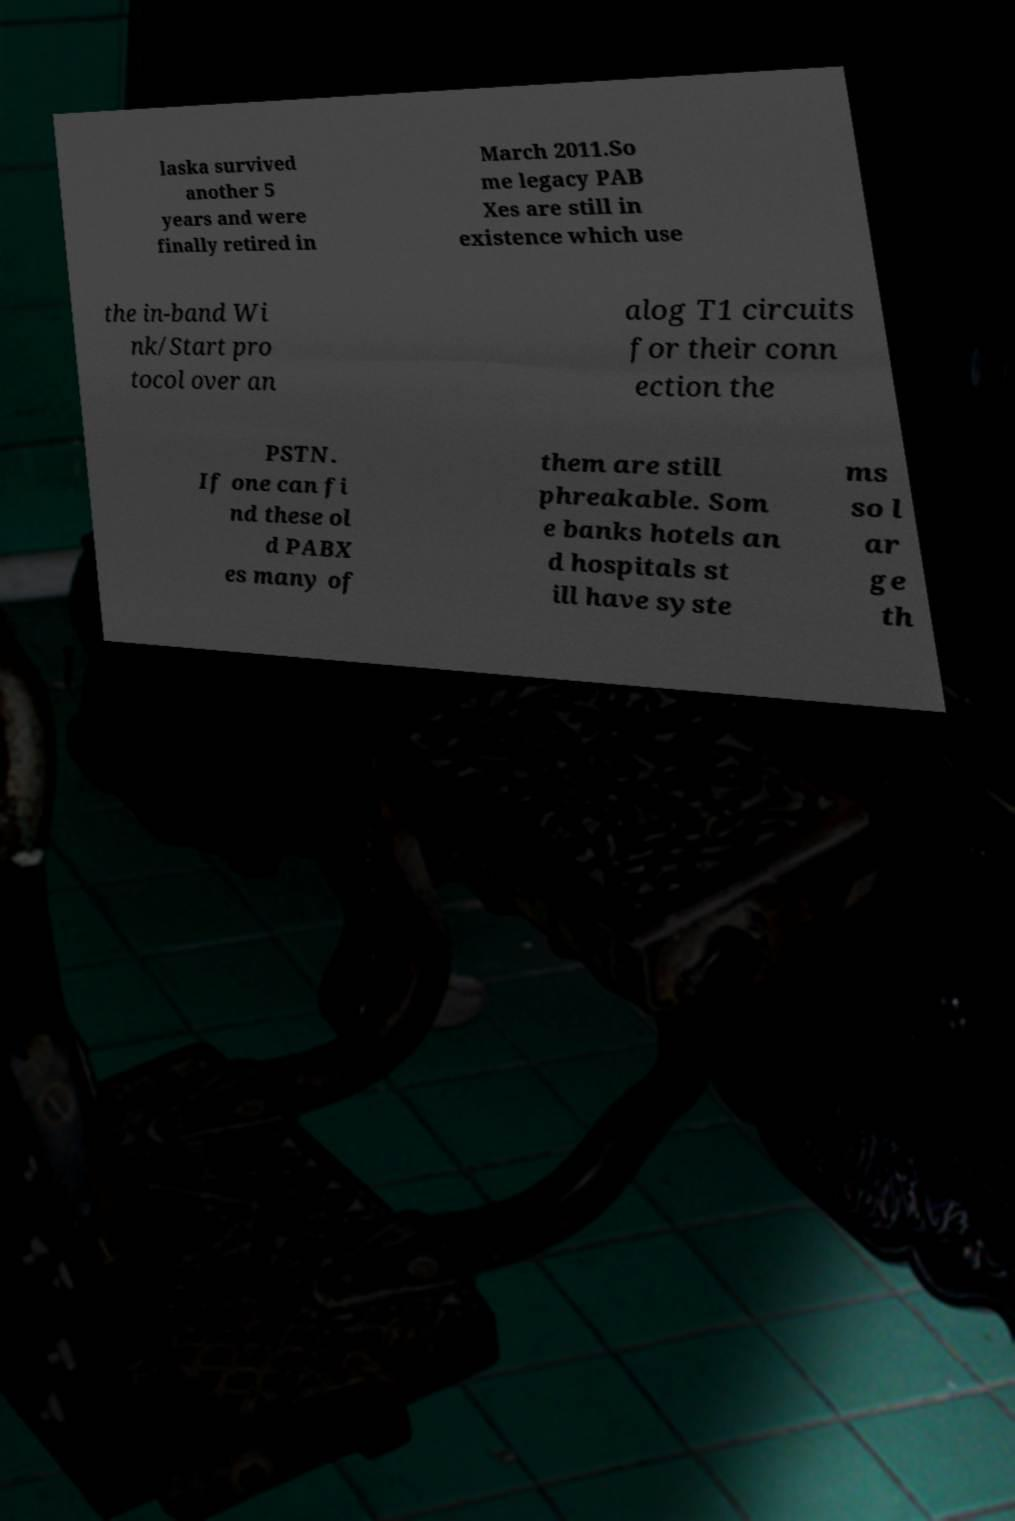There's text embedded in this image that I need extracted. Can you transcribe it verbatim? laska survived another 5 years and were finally retired in March 2011.So me legacy PAB Xes are still in existence which use the in-band Wi nk/Start pro tocol over an alog T1 circuits for their conn ection the PSTN. If one can fi nd these ol d PABX es many of them are still phreakable. Som e banks hotels an d hospitals st ill have syste ms so l ar ge th 